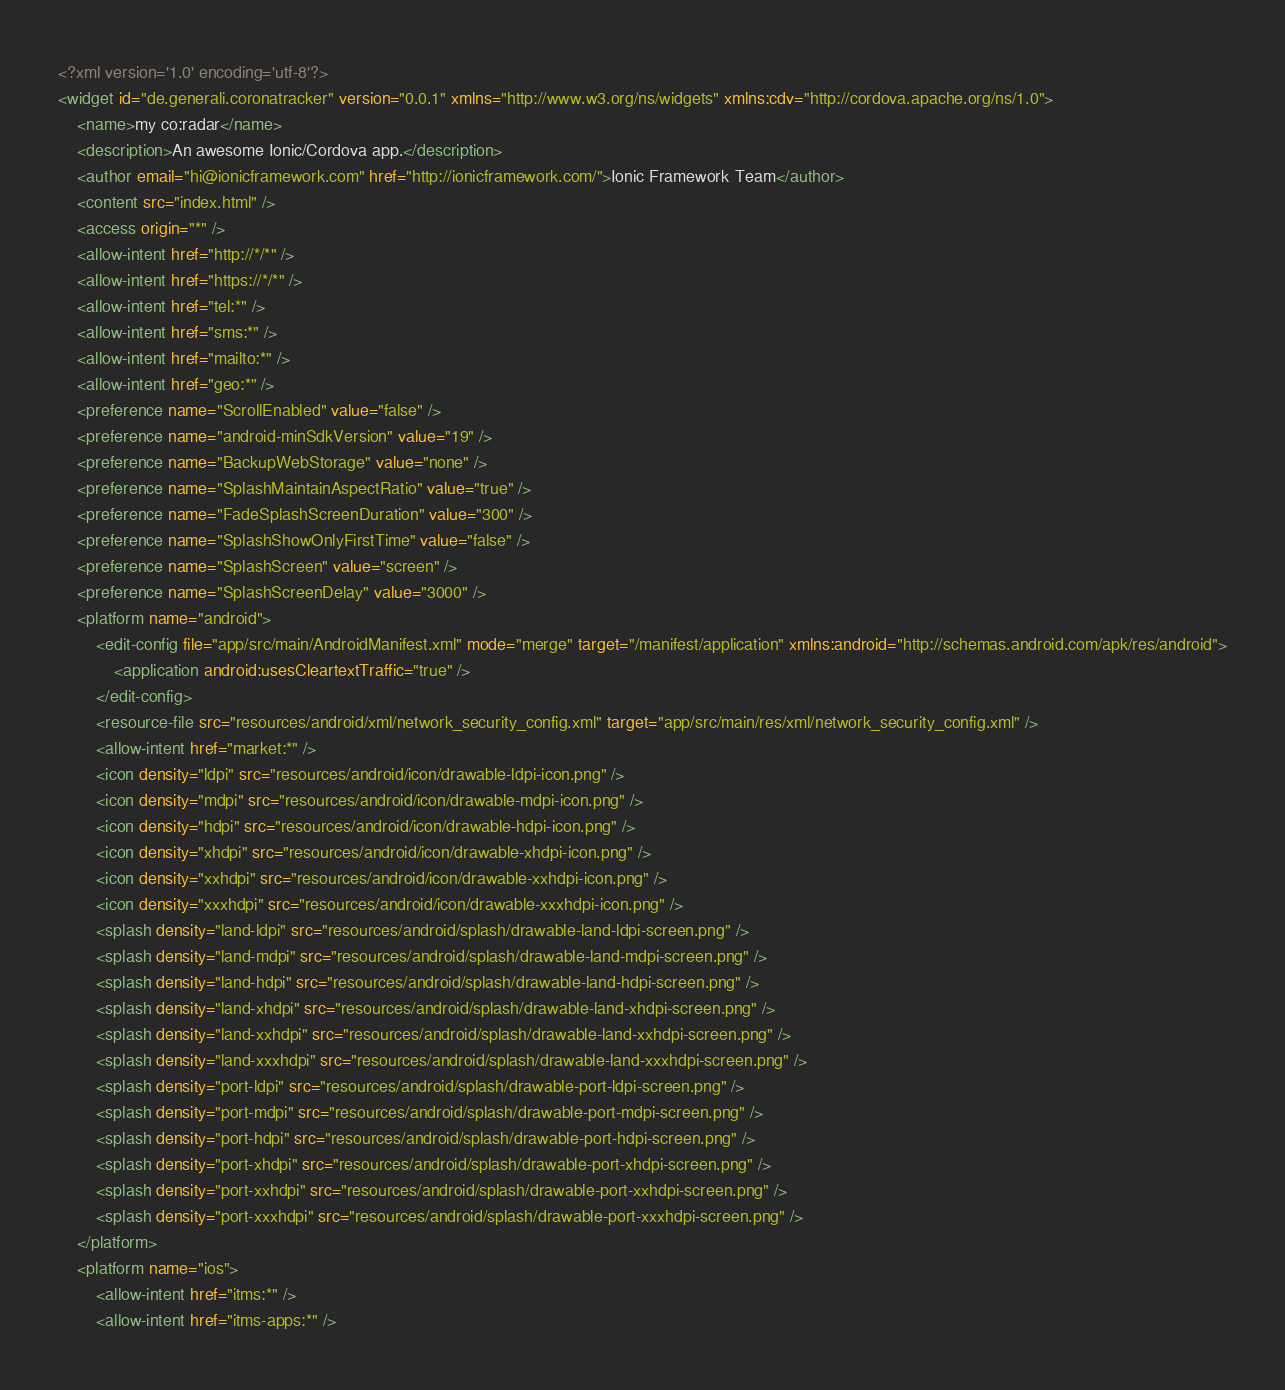Convert code to text. <code><loc_0><loc_0><loc_500><loc_500><_XML_><?xml version='1.0' encoding='utf-8'?>
<widget id="de.generali.coronatracker" version="0.0.1" xmlns="http://www.w3.org/ns/widgets" xmlns:cdv="http://cordova.apache.org/ns/1.0">
    <name>my co:radar</name>
    <description>An awesome Ionic/Cordova app.</description>
    <author email="hi@ionicframework.com" href="http://ionicframework.com/">Ionic Framework Team</author>
    <content src="index.html" />
    <access origin="*" />
    <allow-intent href="http://*/*" />
    <allow-intent href="https://*/*" />
    <allow-intent href="tel:*" />
    <allow-intent href="sms:*" />
    <allow-intent href="mailto:*" />
    <allow-intent href="geo:*" />
    <preference name="ScrollEnabled" value="false" />
    <preference name="android-minSdkVersion" value="19" />
    <preference name="BackupWebStorage" value="none" />
    <preference name="SplashMaintainAspectRatio" value="true" />
    <preference name="FadeSplashScreenDuration" value="300" />
    <preference name="SplashShowOnlyFirstTime" value="false" />
    <preference name="SplashScreen" value="screen" />
    <preference name="SplashScreenDelay" value="3000" />
    <platform name="android">
        <edit-config file="app/src/main/AndroidManifest.xml" mode="merge" target="/manifest/application" xmlns:android="http://schemas.android.com/apk/res/android">
            <application android:usesCleartextTraffic="true" />
        </edit-config>
        <resource-file src="resources/android/xml/network_security_config.xml" target="app/src/main/res/xml/network_security_config.xml" />
        <allow-intent href="market:*" />
        <icon density="ldpi" src="resources/android/icon/drawable-ldpi-icon.png" />
        <icon density="mdpi" src="resources/android/icon/drawable-mdpi-icon.png" />
        <icon density="hdpi" src="resources/android/icon/drawable-hdpi-icon.png" />
        <icon density="xhdpi" src="resources/android/icon/drawable-xhdpi-icon.png" />
        <icon density="xxhdpi" src="resources/android/icon/drawable-xxhdpi-icon.png" />
        <icon density="xxxhdpi" src="resources/android/icon/drawable-xxxhdpi-icon.png" />
        <splash density="land-ldpi" src="resources/android/splash/drawable-land-ldpi-screen.png" />
        <splash density="land-mdpi" src="resources/android/splash/drawable-land-mdpi-screen.png" />
        <splash density="land-hdpi" src="resources/android/splash/drawable-land-hdpi-screen.png" />
        <splash density="land-xhdpi" src="resources/android/splash/drawable-land-xhdpi-screen.png" />
        <splash density="land-xxhdpi" src="resources/android/splash/drawable-land-xxhdpi-screen.png" />
        <splash density="land-xxxhdpi" src="resources/android/splash/drawable-land-xxxhdpi-screen.png" />
        <splash density="port-ldpi" src="resources/android/splash/drawable-port-ldpi-screen.png" />
        <splash density="port-mdpi" src="resources/android/splash/drawable-port-mdpi-screen.png" />
        <splash density="port-hdpi" src="resources/android/splash/drawable-port-hdpi-screen.png" />
        <splash density="port-xhdpi" src="resources/android/splash/drawable-port-xhdpi-screen.png" />
        <splash density="port-xxhdpi" src="resources/android/splash/drawable-port-xxhdpi-screen.png" />
        <splash density="port-xxxhdpi" src="resources/android/splash/drawable-port-xxxhdpi-screen.png" />
    </platform>
    <platform name="ios">
        <allow-intent href="itms:*" />
        <allow-intent href="itms-apps:*" /></code> 